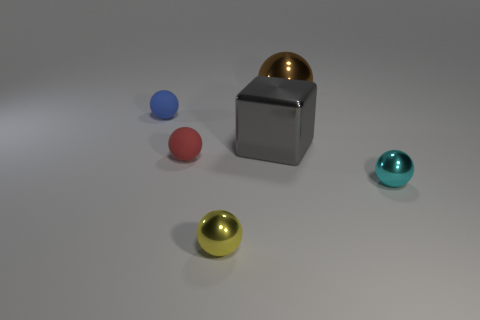Add 3 large brown shiny balls. How many objects exist? 9 Subtract all blue balls. How many balls are left? 4 Subtract all cyan balls. How many balls are left? 4 Subtract all blocks. How many objects are left? 5 Subtract 2 spheres. How many spheres are left? 3 Subtract all green blocks. How many cyan spheres are left? 1 Add 4 tiny blue spheres. How many tiny blue spheres exist? 5 Subtract 0 red blocks. How many objects are left? 6 Subtract all cyan cubes. Subtract all brown cylinders. How many cubes are left? 1 Subtract all red rubber things. Subtract all small yellow metallic things. How many objects are left? 4 